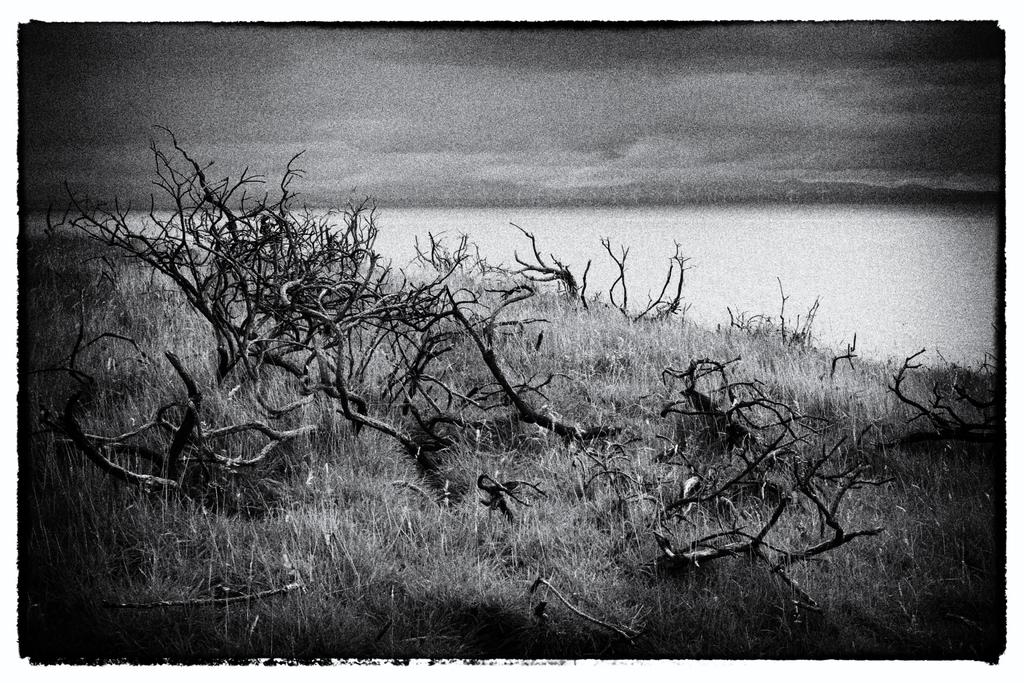What is the color scheme of the image? The image is black and white. What type of surface can be seen in the image? There is grass on the surface in the image. What natural feature is present in the image? There is a river in the image. What type of twig is being used to stir the river in the image? There is no twig present in the image, nor is anything being used to stir the river. 